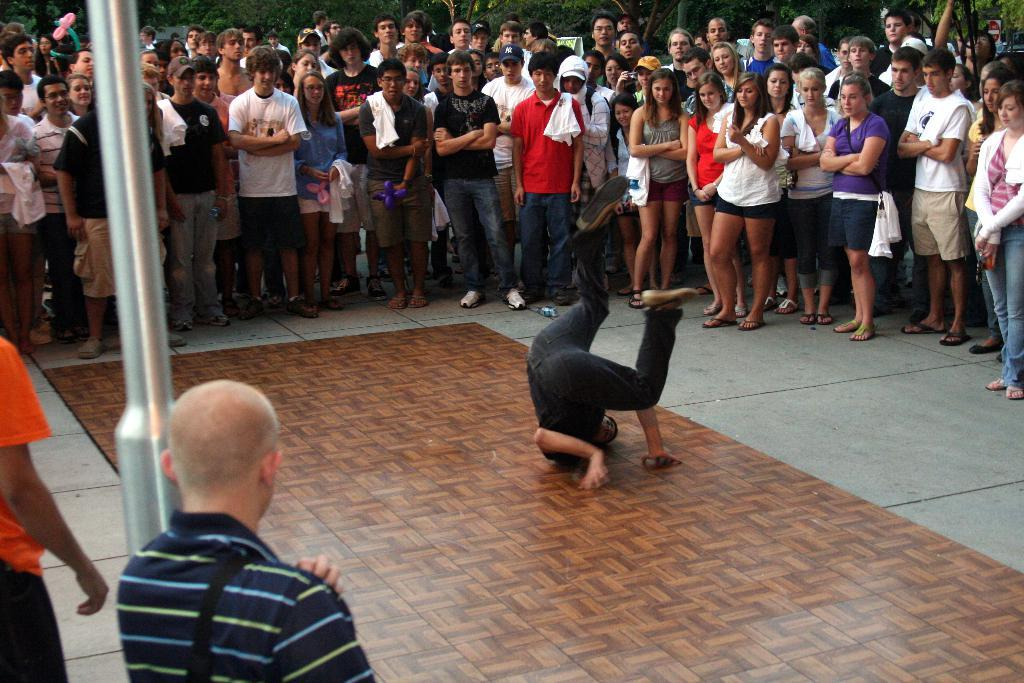What is located in the middle of the image? There is a carpet in the middle of the image. What is the person on the carpet doing? A person is doing jumps on the carpet. Where are the groups of people located in the image? There are groups of people on both the left and right sides of the image. What type of food is being served to the beggar in the image? There is no beggar or food present in the image. What is the person rubbing on the carpet in the image? There is no person rubbing anything on the carpet in the image; the person is jumping on it. 